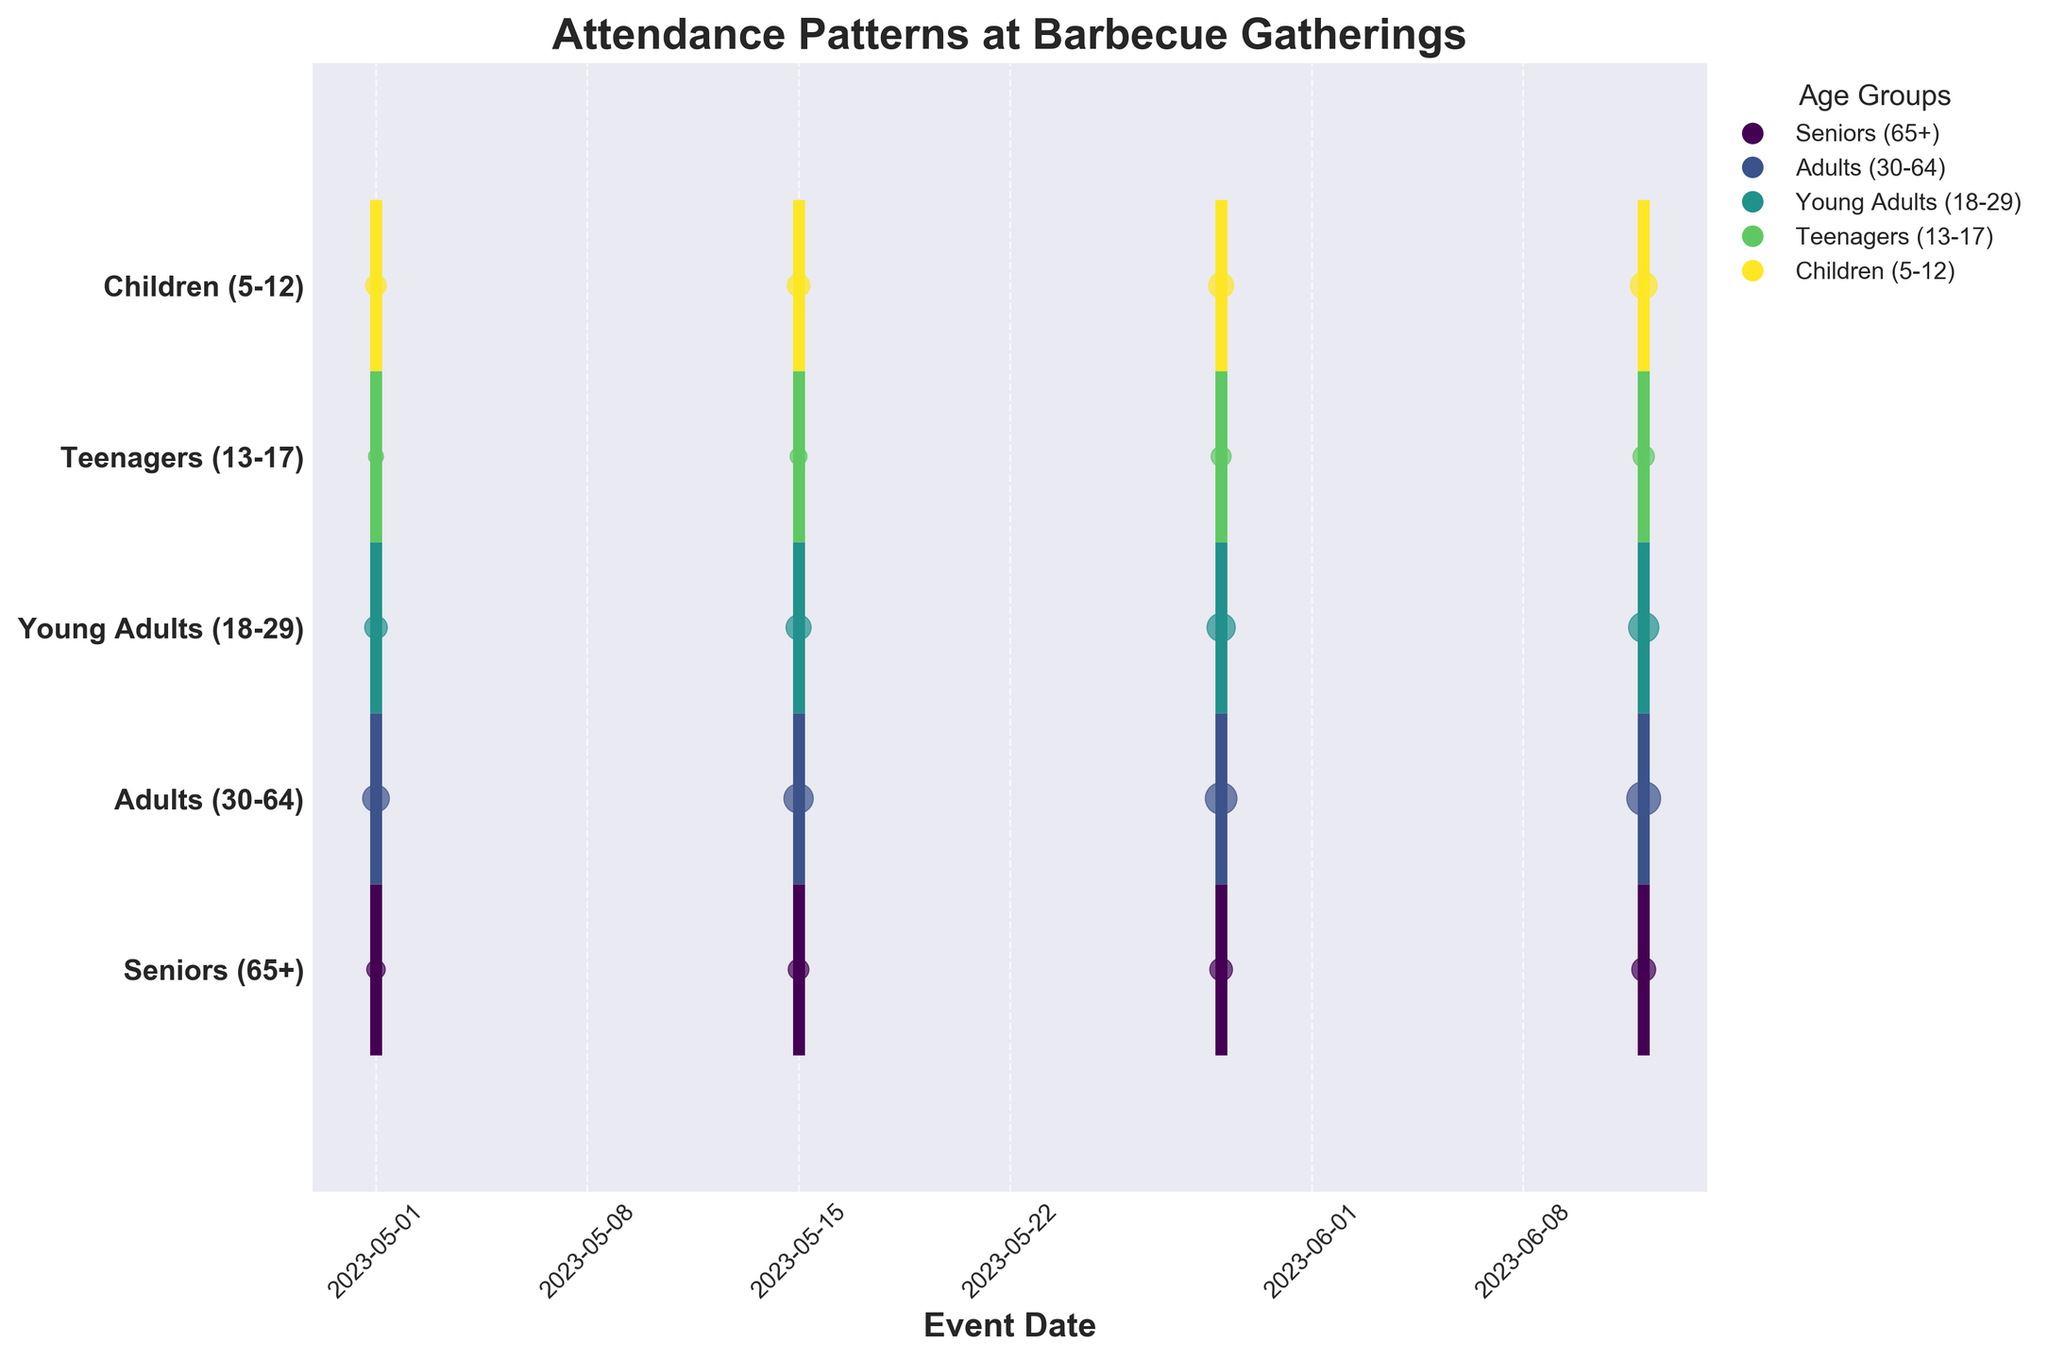What is the title of the figure? The title is prominently displayed at the top of the figure, often in larger or bold text. It provides a summary of what the figure is about. The specific wording in the title of this figure is "Attendance Patterns at Barbecue Gatherings".
Answer: Attendance Patterns at Barbecue Gatherings Which age group had the highest attendance on June 12, 2023? Look at the eventplot and find the data points corresponding to June 12, 2023. Compare the sizes of the scatter points for each age group, as larger sizes signify higher attendance. The "Adults (30-64)" group has the largest scatter point on this date.
Answer: Adults (30-64) How many unique age groups are represented in the figure? Identify the distinct categories represented along the y-axis, each marked by a different color and label. Counting these labels tells us the number of unique age groups. There are five age groups: Seniors (65+), Adults (30-64), Young Adults (18-29), Teenagers (13-17), and Children (5-12).
Answer: 5 What is the attendance trend for the "Teenagers (13-17)" group throughout the events? Observe the eventplot for the "Teenagers (13-17)" group across all dates. Notice the scatter points become larger over time, indicating increasing attendance. The trend shows growth from 8 on May 1 to 16 on June 12.
Answer: Increasing Which two age groups had the closest attendance numbers on May 29, 2023? Check the scatter points on May 29, 2023 across different age groups and compare their sizes. The sizes for "Teenagers (13-17)" and "Children (5-12)" are quite close on this date.
Answer: Teenagers (13-17) and Children (5-12) What can be inferred about the overall attendance patterns from May 1 to June 12? Examine the scatter points for each age group over the given dates. Notice that, in general, the sizes of the points increase, indicating that attendance increased for all age groups over time.
Answer: Overall attendance increased Which age group had the lowest attendance on May 15, 2023, and what was the attendance number? Identify the scatter points on May 15, 2023 and compare their sizes. The smallest point corresponds to the "Teenagers (13-17)" group, with an attendance of 10.
Answer: Teenagers (13-17), 10 Compare the attendance trends of "Seniors (65+)" and "Young Adults (18-29)" over all events. Which group had a sharper increase? Look at the sizes of the scatter points for both age groups across all dates. The "Young Adults (18-29)" group shows a sharper increase in attendance from 18 to 32, while the "Seniors (65+)" increased from 12 to 20.
Answer: Young Adults (18-29) What is the attendance difference between "Children (5-12)" and "Adults (30-64)" on June 12, 2023? Find the scatter points for both age groups on June 12, 2023 and subtract the attendance number of "Children (5-12)" from that of "Adults (30-64)" (40 - 25 = 15).
Answer: 15 